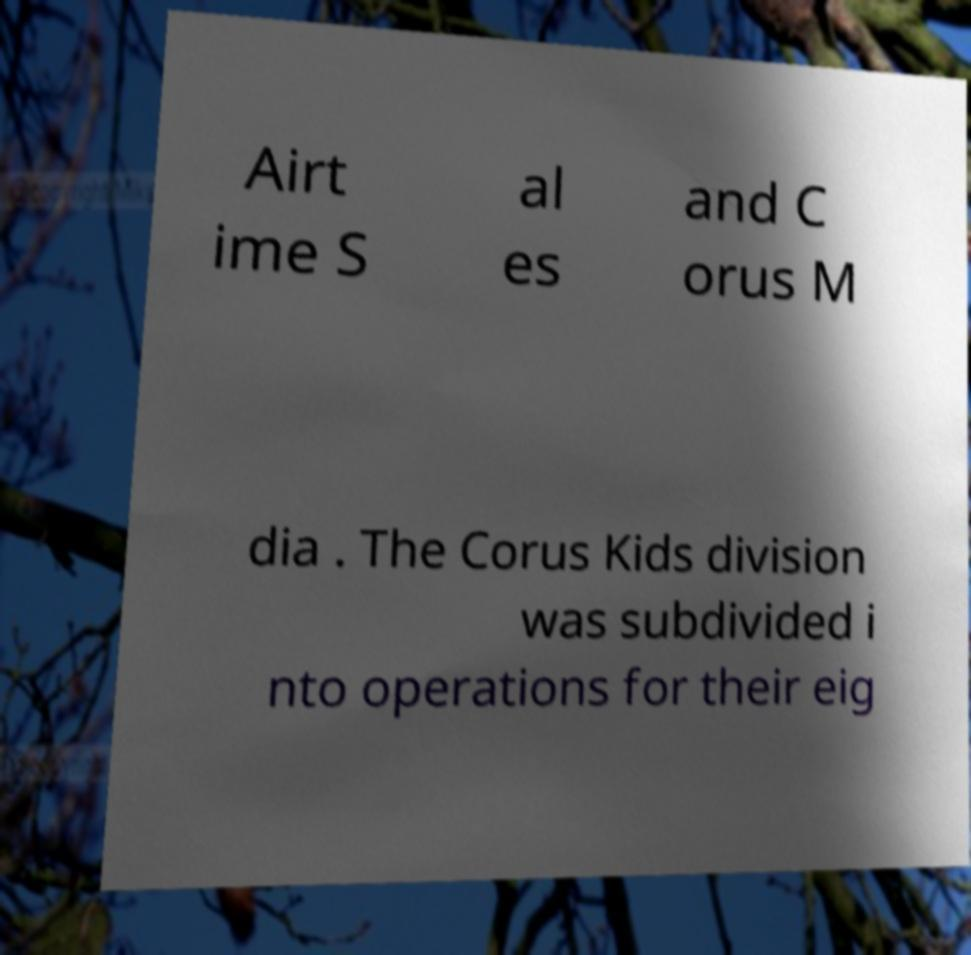Can you read and provide the text displayed in the image?This photo seems to have some interesting text. Can you extract and type it out for me? Airt ime S al es and C orus M dia . The Corus Kids division was subdivided i nto operations for their eig 